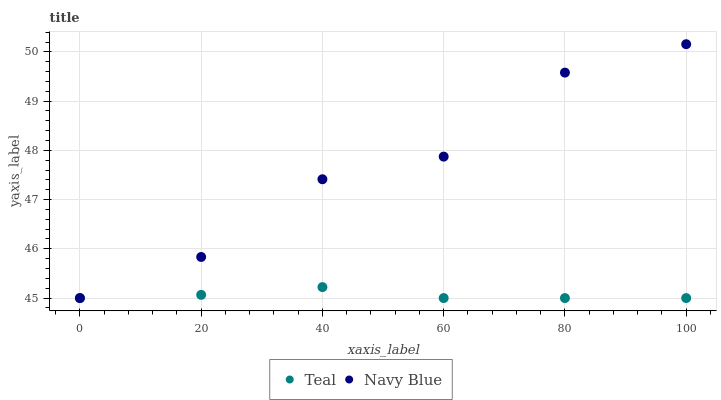Does Teal have the minimum area under the curve?
Answer yes or no. Yes. Does Navy Blue have the maximum area under the curve?
Answer yes or no. Yes. Does Teal have the maximum area under the curve?
Answer yes or no. No. Is Teal the smoothest?
Answer yes or no. Yes. Is Navy Blue the roughest?
Answer yes or no. Yes. Is Teal the roughest?
Answer yes or no. No. Does Navy Blue have the lowest value?
Answer yes or no. Yes. Does Navy Blue have the highest value?
Answer yes or no. Yes. Does Teal have the highest value?
Answer yes or no. No. Does Teal intersect Navy Blue?
Answer yes or no. Yes. Is Teal less than Navy Blue?
Answer yes or no. No. Is Teal greater than Navy Blue?
Answer yes or no. No. 